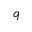<formula> <loc_0><loc_0><loc_500><loc_500>q</formula> 